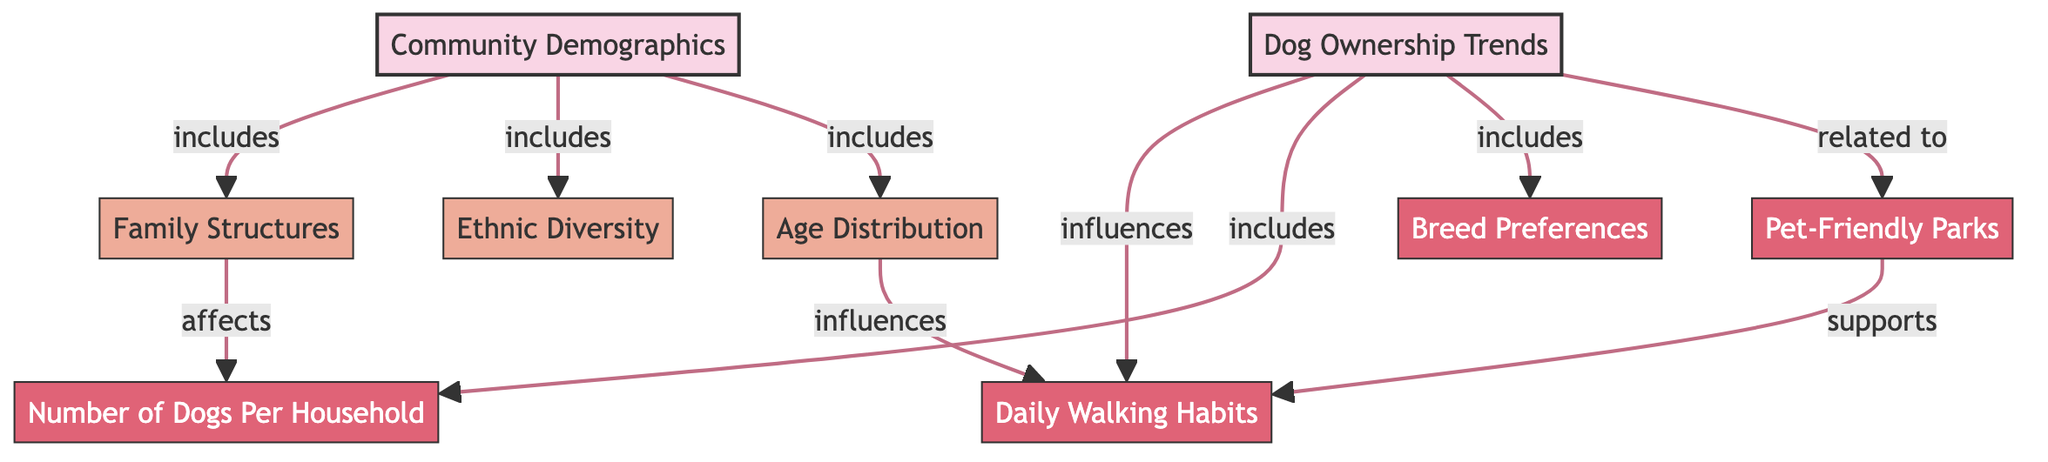What are the main topics represented in the diagram? The main topics are identified as "Community Demographics" and "Dog Ownership Trends." These are the highest-level nodes in the diagram.
Answer: Community Demographics and Dog Ownership Trends How many subtopics are included under "Community Demographics"? The subtopics included under "Community Demographics" are "Age Distribution," "Ethnic Diversity," and "Family Structures." This gives us a total of 3 subtopics.
Answer: 3 Which subtopic under "Dog Ownership Trends" relates specifically to parks? The subtopic that relates specifically to parks is "Pet-Friendly Parks." This shows a direct connection to dog ownership and community facilities.
Answer: Pet-Friendly Parks How does "Family Structures" affect "Number of Dogs Per Household"? "Family Structures" has a direct effect on "Number of Dogs Per Household," indicating that different family setups can influence how many dogs families choose to have. This shows an interdependence in the diagram.
Answer: Affects What influences "Daily Walking Habits" according to the diagram? "Daily Walking Habits" is influenced by both "Age Distribution" and "Pet-Friendly Parks," indicating that these factors are related to how frequently people walk their dogs.
Answer: Age Distribution and Pet-Friendly Parks What is the relationship between "Dog Ownership Trends" and "Daily Walking Habits"? "Dog Ownership Trends" influences "Daily Walking Habits," suggesting that the trends in dog ownership can impact how often residents walk their dogs.
Answer: Influences Which node supports "Daily Walking Habits"? The node that supports "Daily Walking Habits" is "Pet-Friendly Parks," as access to suitable areas for walking dogs can encourage more regular walking behaviors.
Answer: Pet-Friendly Parks What subtopic under "Dog Ownership Trends" involves specific dog types? The subtopic that involves specific dog types is "Breed Preferences," which refers to the types of dog breeds that are favored within the community.
Answer: Breed Preferences 